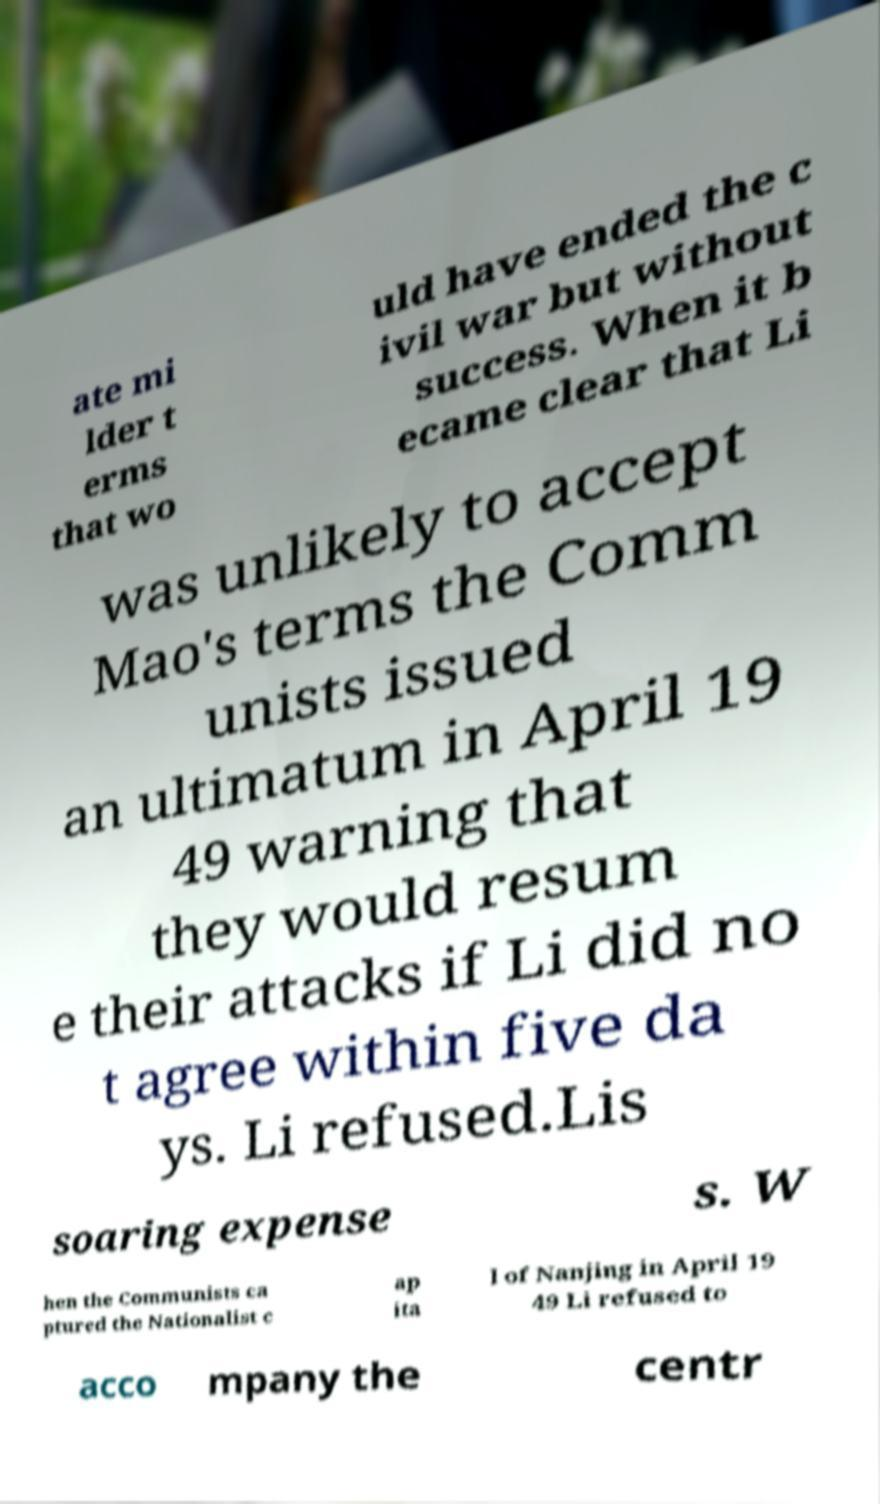Please identify and transcribe the text found in this image. ate mi lder t erms that wo uld have ended the c ivil war but without success. When it b ecame clear that Li was unlikely to accept Mao's terms the Comm unists issued an ultimatum in April 19 49 warning that they would resum e their attacks if Li did no t agree within five da ys. Li refused.Lis soaring expense s. W hen the Communists ca ptured the Nationalist c ap ita l of Nanjing in April 19 49 Li refused to acco mpany the centr 